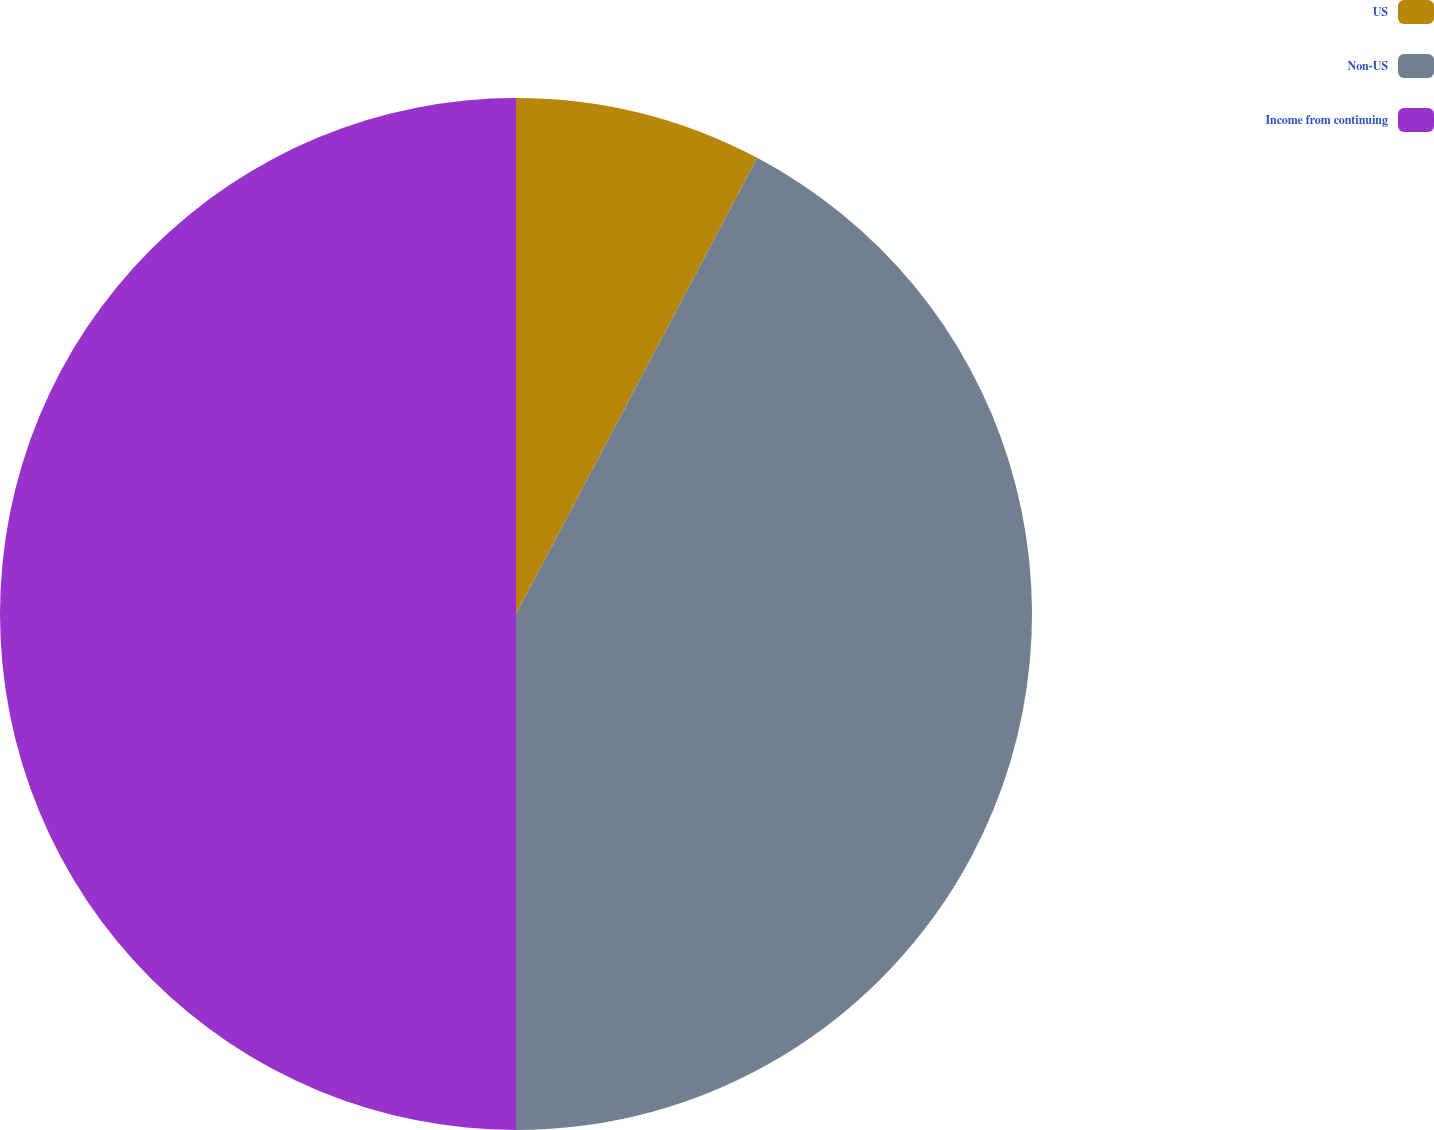Convert chart to OTSL. <chart><loc_0><loc_0><loc_500><loc_500><pie_chart><fcel>US<fcel>Non-US<fcel>Income from continuing<nl><fcel>7.74%<fcel>42.26%<fcel>50.0%<nl></chart> 